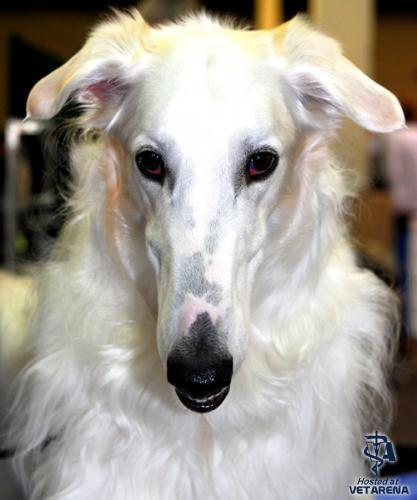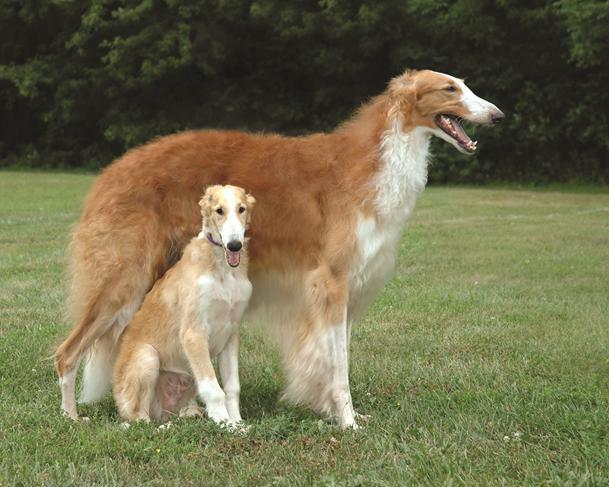The first image is the image on the left, the second image is the image on the right. Analyze the images presented: Is the assertion "One image includes at least twice as many hounds in the foreground as the other image." valid? Answer yes or no. Yes. The first image is the image on the left, the second image is the image on the right. Examine the images to the left and right. Is the description "There are two dogs in total." accurate? Answer yes or no. No. 